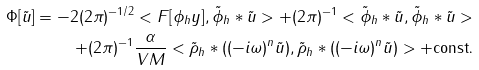Convert formula to latex. <formula><loc_0><loc_0><loc_500><loc_500>\Phi [ \tilde { u } ] = - 2 ( 2 \pi ) ^ { - 1 / 2 } < F [ \phi _ { h } y ] , \tilde { \phi } _ { h } * \tilde { u } > + ( 2 \pi ) ^ { - 1 } < \tilde { \phi } _ { h } * \tilde { u } , \tilde { \phi } _ { h } * \tilde { u } > \\ + ( 2 \pi ) ^ { - 1 } \frac { \alpha } { V M } < \tilde { \rho } _ { h } * ( ( - i \omega ) ^ { n } \tilde { u } ) , \tilde { \rho } _ { h } * ( ( - i \omega ) ^ { n } \tilde { u } ) > + \text {const.}</formula> 